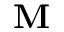Convert formula to latex. <formula><loc_0><loc_0><loc_500><loc_500>M</formula> 